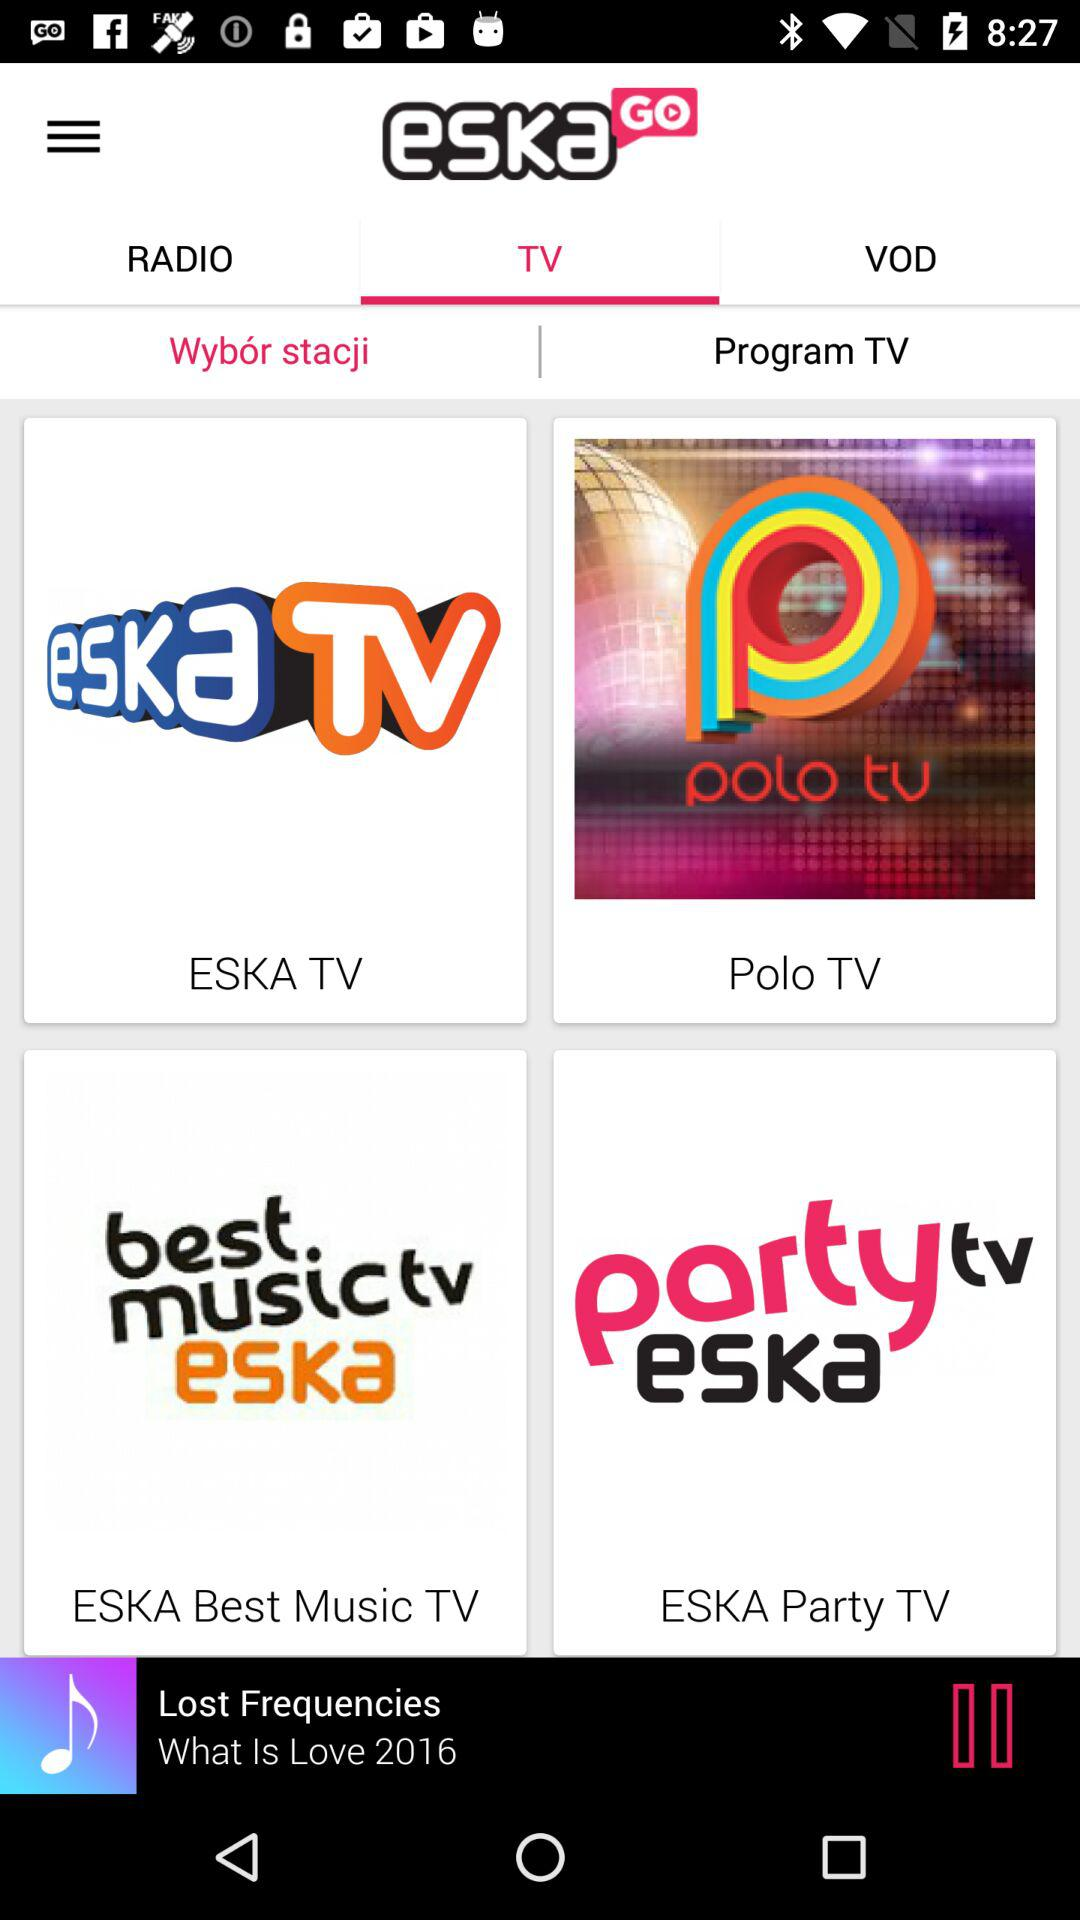Which tab is selected? The selected tabs are "TV" and "Wybór stacji". 